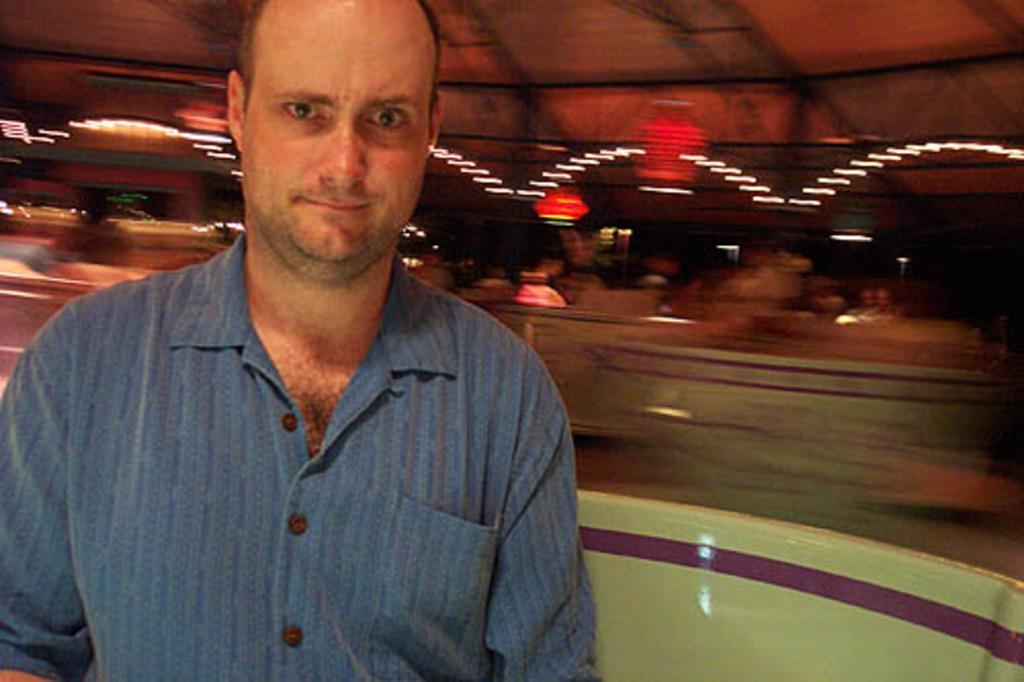In one or two sentences, can you explain what this image depicts? In the front of the image I can see a person and white object. In the background of the image it is blurry. I can able to see lights and objects. 